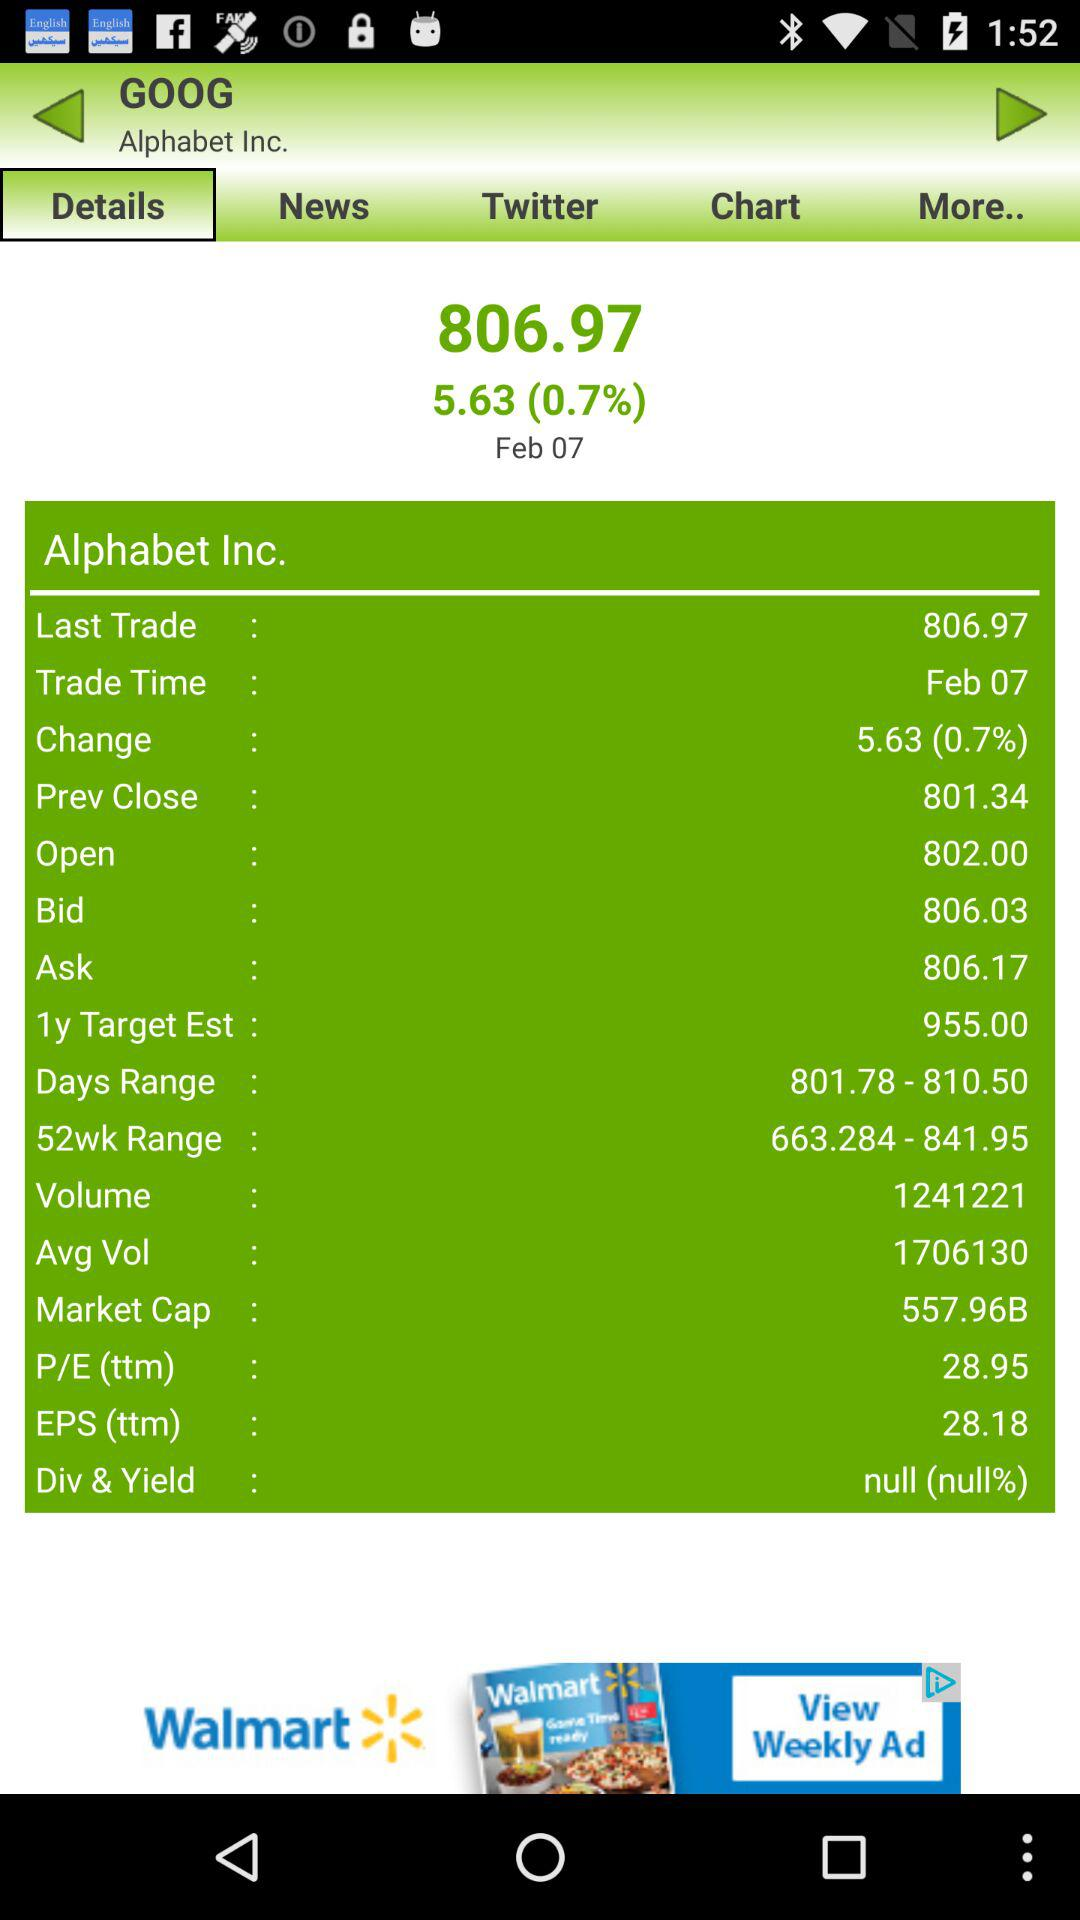Which tab is selected? The selected tab is "Details". 